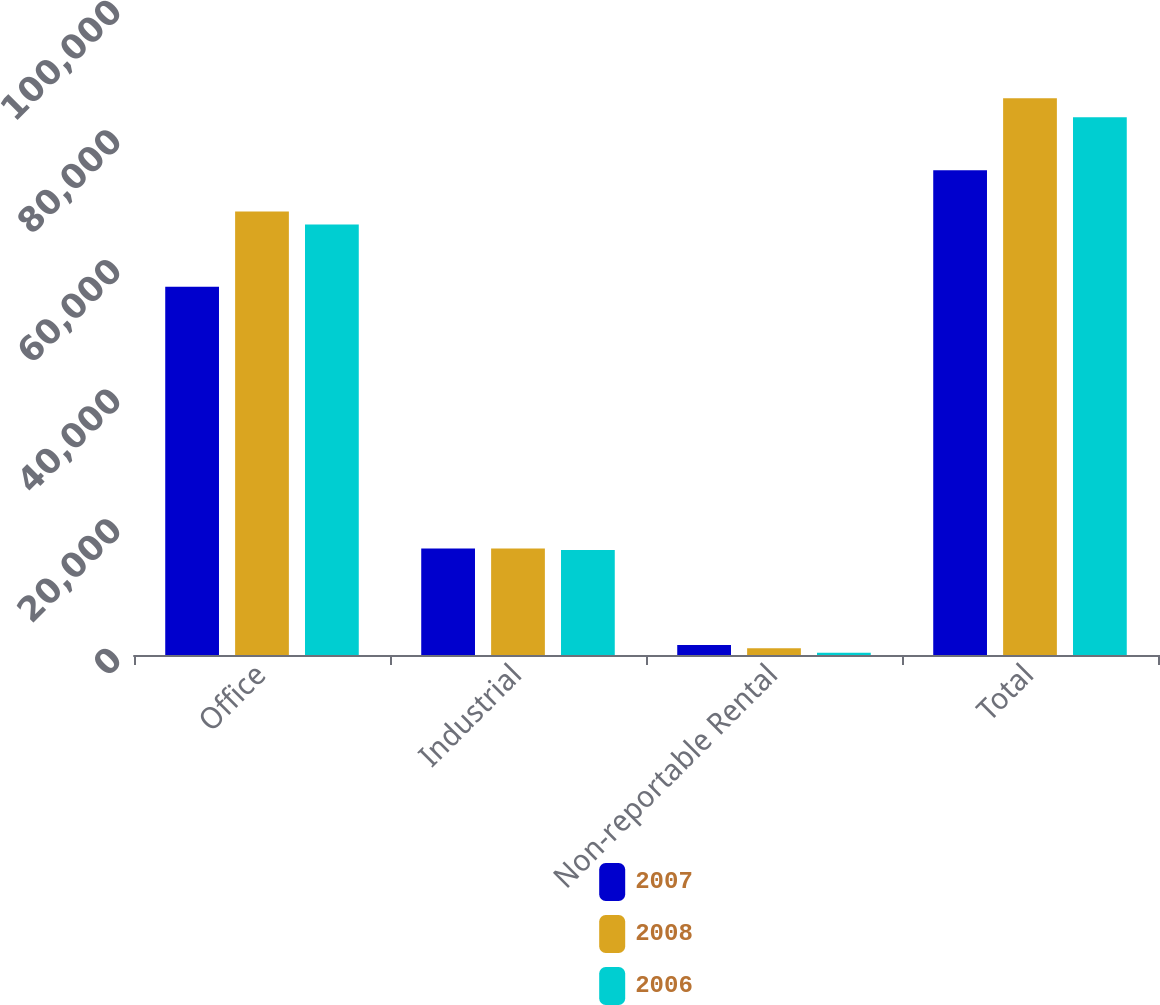Convert chart to OTSL. <chart><loc_0><loc_0><loc_500><loc_500><stacked_bar_chart><ecel><fcel>Office<fcel>Industrial<fcel>Non-reportable Rental<fcel>Total<nl><fcel>2007<fcel>56844<fcel>16443<fcel>1527<fcel>74814<nl><fcel>2008<fcel>68427<fcel>16454<fcel>1055<fcel>85936<nl><fcel>2006<fcel>66449<fcel>16210<fcel>341<fcel>83000<nl></chart> 